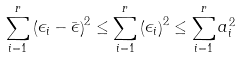Convert formula to latex. <formula><loc_0><loc_0><loc_500><loc_500>\sum _ { i = 1 } ^ { r } \left ( \epsilon _ { i } - \bar { \epsilon } \right ) ^ { 2 } \leq \sum _ { i = 1 } ^ { r } \left ( \epsilon _ { i } \right ) ^ { 2 } \leq \sum _ { i = 1 } ^ { r } a _ { i } ^ { 2 }</formula> 